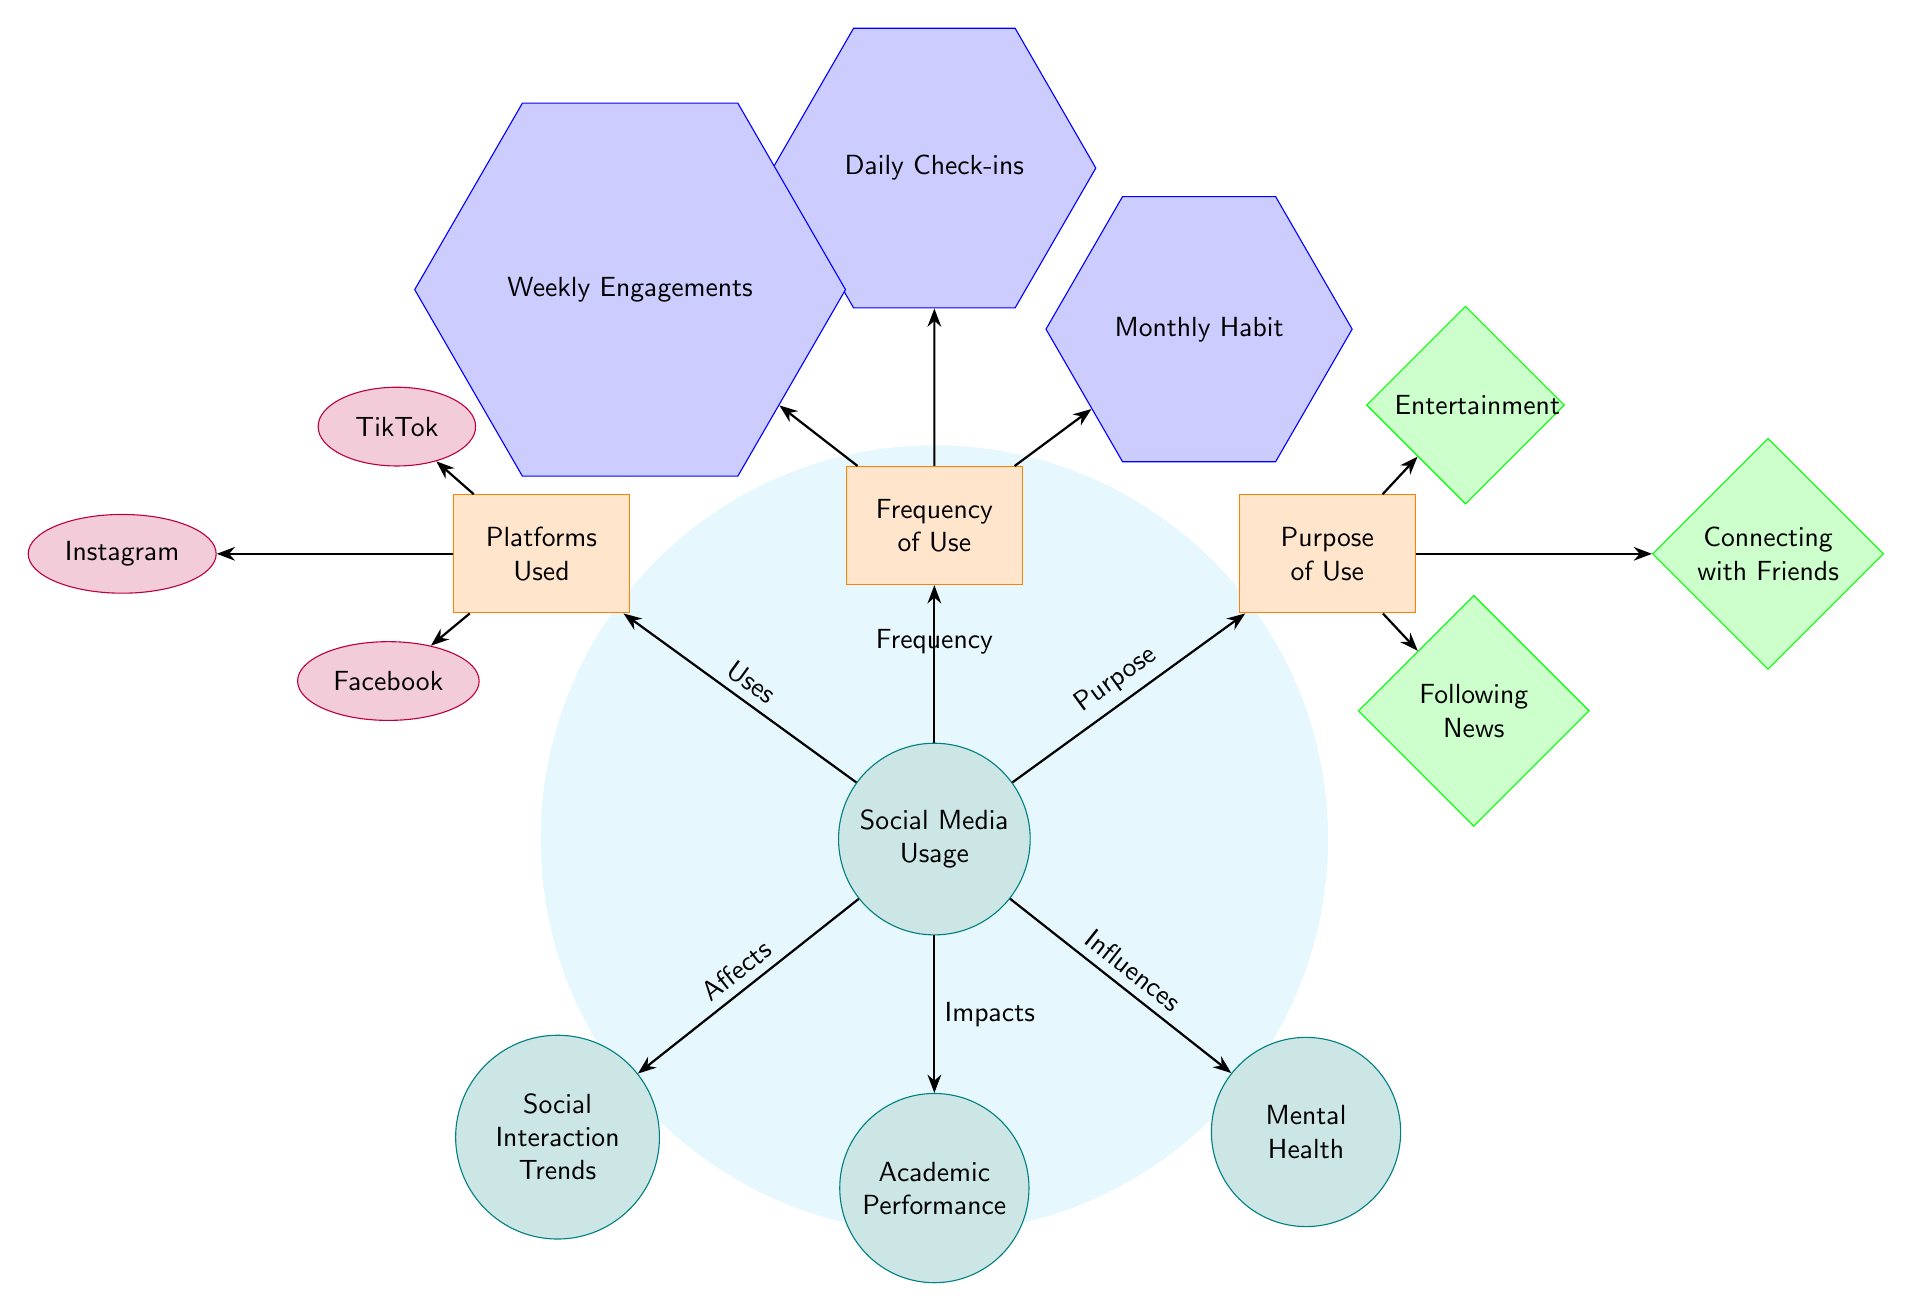What is the main node in the diagram? The main node is labeled "Social Media Usage," which is positioned centrally in the diagram and connects to other nodes.
Answer: Social Media Usage How many platforms are indicated in the diagram? There are three platform nodes shown: Instagram, TikTok, and Facebook, which are connected to the "Platforms Used" node.
Answer: 3 What purpose of social media usage is associated with connecting with friends? "Connecting with Friends" is one of the purposes listed under the "Purpose of Use" node and is directly connected to that node.
Answer: Connecting with Friends Which node is influenced by Social Media Usage and indicates a negative aspect? "Mental Health" is influenced by social media usage and implies a potential negative aspect, as shown by the arrow labeled "Influences."
Answer: Mental Health What type of node connects "Frequency of Use" to "Daily Check-ins"? "Daily Check-ins" is classified as a "frequency node," which signifies the frequency of social media usage in the diagram.
Answer: Frequency node Which social media platform is not listed in the diagram? The platform "Twitter" is not listed, as the three platforms mentioned are Instagram, TikTok, and Facebook, showing platform variety.
Answer: Twitter What is the relationship between "Social Media Usage" and "Academic Performance"? The diagram shows that "Social Media Usage" directly impacts "Academic Performance," indicated by the arrow labeled "Impacts."
Answer: Impacts Which frequency option indicates less frequent social media engagement? "Monthly Habit" is the least frequent engagement option, compared to "Daily Check-ins" and "Weekly Engagements."
Answer: Monthly Habit Why are the sub nodes positioned above and below the main node? The sub nodes represent components of social media usage, with platforms, frequency, and purpose above, and their related impacts below, illustrating a flow of information.
Answer: Information flow 